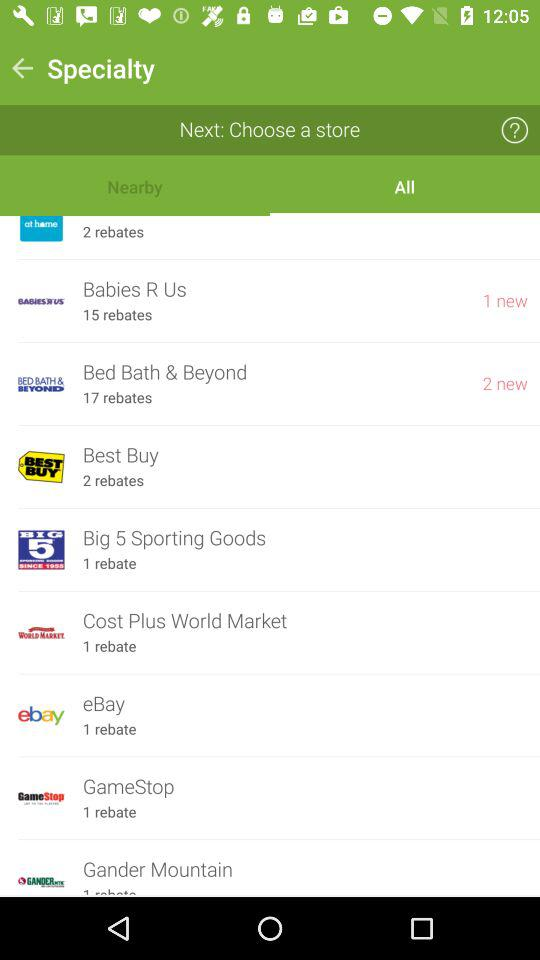How many new notifications has "Babies R Us" received? There is 1 new notification. 